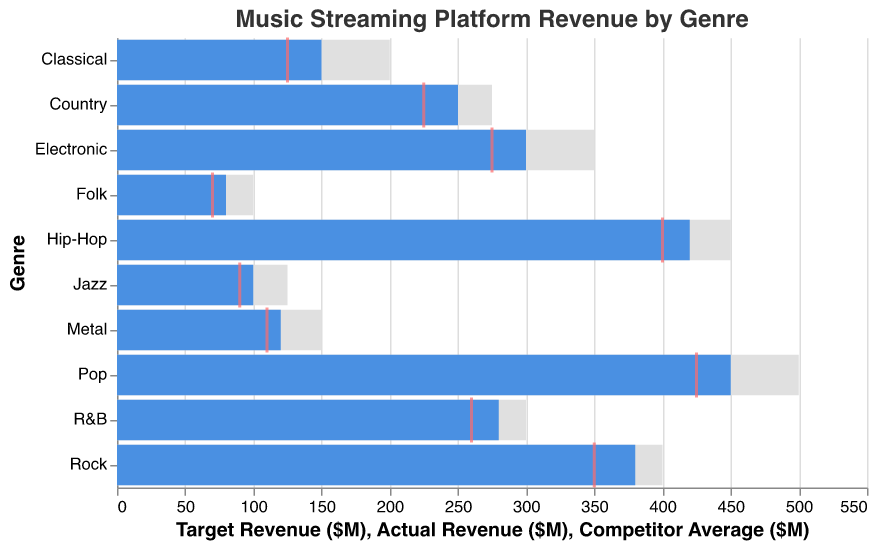What's the genre with the highest actual revenue? By looking at the blue bars which represent actual revenue, Pop has the highest bar.
Answer: Pop What's the genre with the lowest actual revenue? By examining the blue bars which represent actual revenue, Folk has the shortest bar.
Answer: Folk How much higher is the actual revenue of Rock compared to Jazz? The actual revenue of Rock is 380M and Jazz is 100M. The difference is 380M - 100M = 280M.
Answer: 280M Which genre has the largest gap between actual revenue and target revenue? To determine the largest gap, we need to check the difference between the blue bar (actual revenue) and the gray bar (target revenue) for each genre. Pop has a gap of 50M.
Answer: Pop How did Classical perform compared to its target revenue? Classical has an actual revenue of 150M and a target revenue of 200M. Classical's actual revenue is 50M less than its target revenue.
Answer: 50M less Which genre has a competitor average higher than its actual revenue but lower than its target revenue? For Hip-Hop, the competitor average is 400M, which is higher than its actual revenue of 420M but lower than its target revenue of 450M.
Answer: Hip-Hop What's the actual revenue of genres that have their actual revenue smaller than the competitor average? The genres are Classical, Jazz, and Folk with actual revenues of 150M, 100M, and 80M respectively. Summing these gives 150M + 100M + 80M = 330M.
Answer: 330M Which genre has the smallest gap between competitor average and target revenue? For Jazz, the competitor average is 90M and the target revenue is 125M. The gap is 125M - 90M = 35M, which is the smallest gap.
Answer: Jazz If we increase the actual revenue of Metal by 30M, how will it compare to its target revenue? Metal's current actual revenue is 120M. Increasing it by 30M gives 120M + 30M = 150M. Its target revenue is 150M, so it will meet its target revenue exactly.
Answer: Meet target Which genre could be improving its strategies as it’s performing close to or above the competitor average? Genres with actual revenue close to or above the competitor average include Pop, Rock, Hip-Hop, Electronic, Country, R&B.
Answer: Pop, Rock, Hip-Hop, Electronic, Country, R&B 